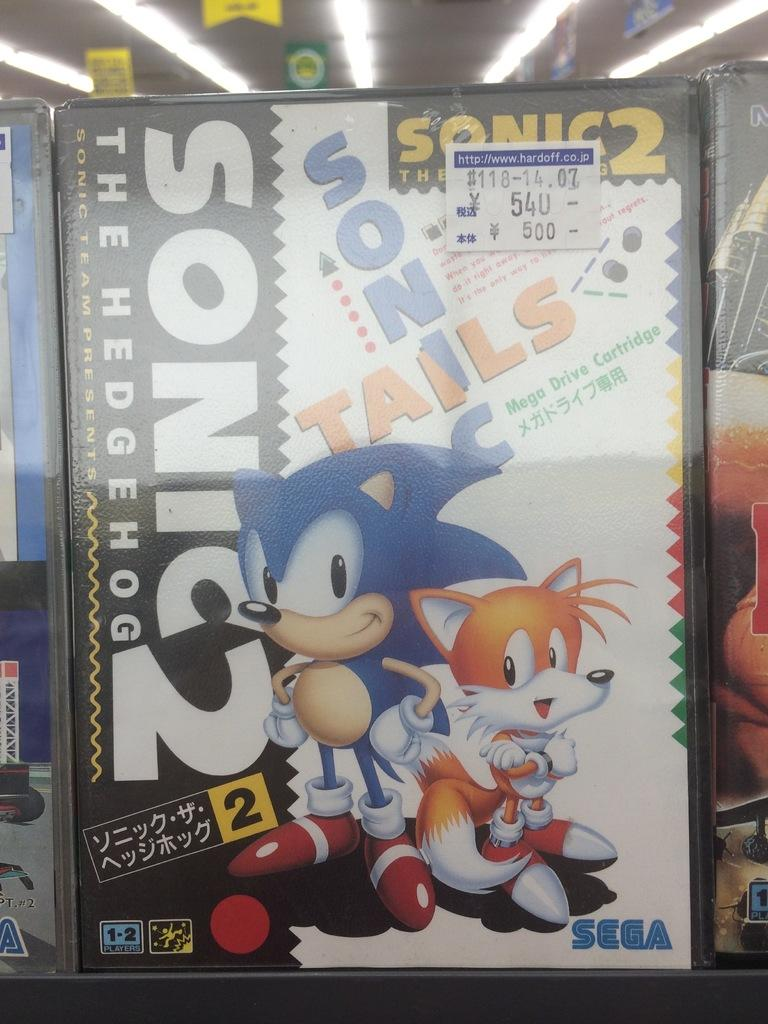What is the main object in the image? There is a box in the image. What is depicted on the box? The box has cartoons on it. Is there any text on the box? Yes, there is writing on the box. What can be seen at the top of the box? There are lights at the top of the box. Where might this image have been taken? The image might have been taken in a store. What type of sound does the box make in the image? There is no information about the box making any sound in the image. 